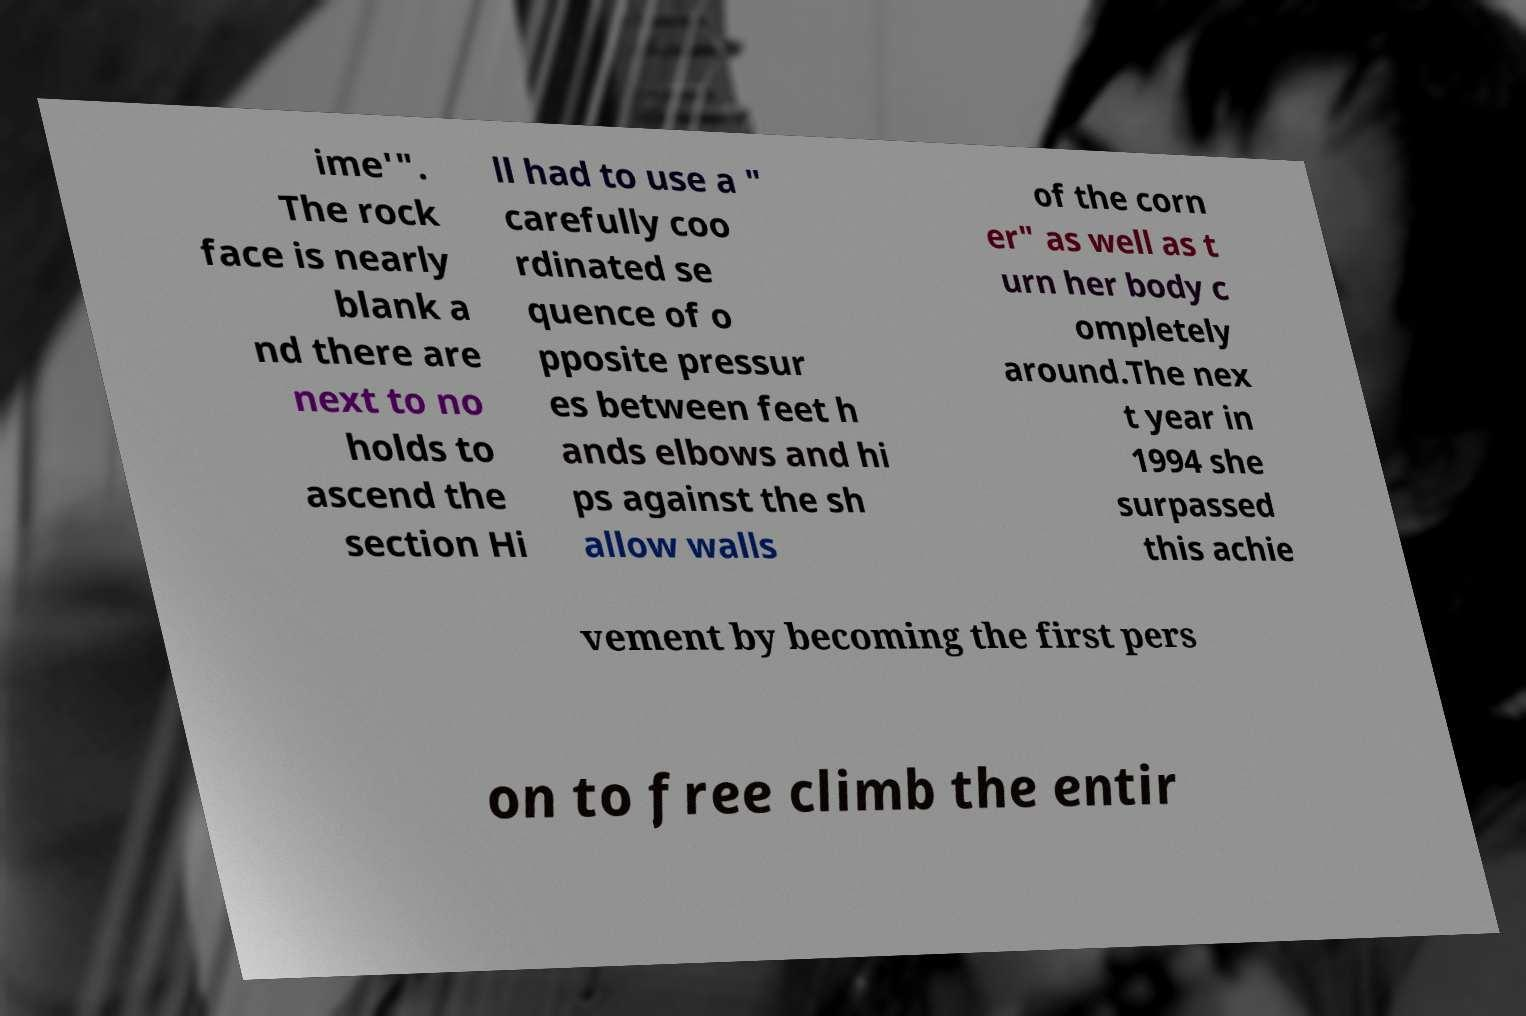For documentation purposes, I need the text within this image transcribed. Could you provide that? ime'". The rock face is nearly blank a nd there are next to no holds to ascend the section Hi ll had to use a " carefully coo rdinated se quence of o pposite pressur es between feet h ands elbows and hi ps against the sh allow walls of the corn er" as well as t urn her body c ompletely around.The nex t year in 1994 she surpassed this achie vement by becoming the first pers on to free climb the entir 